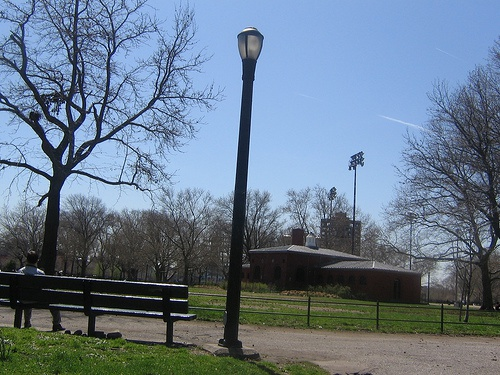Describe the objects in this image and their specific colors. I can see bench in lightblue, black, gray, darkgray, and navy tones, people in lightblue, black, gray, and darkgreen tones, and people in lightblue, black, navy, gray, and darkgray tones in this image. 